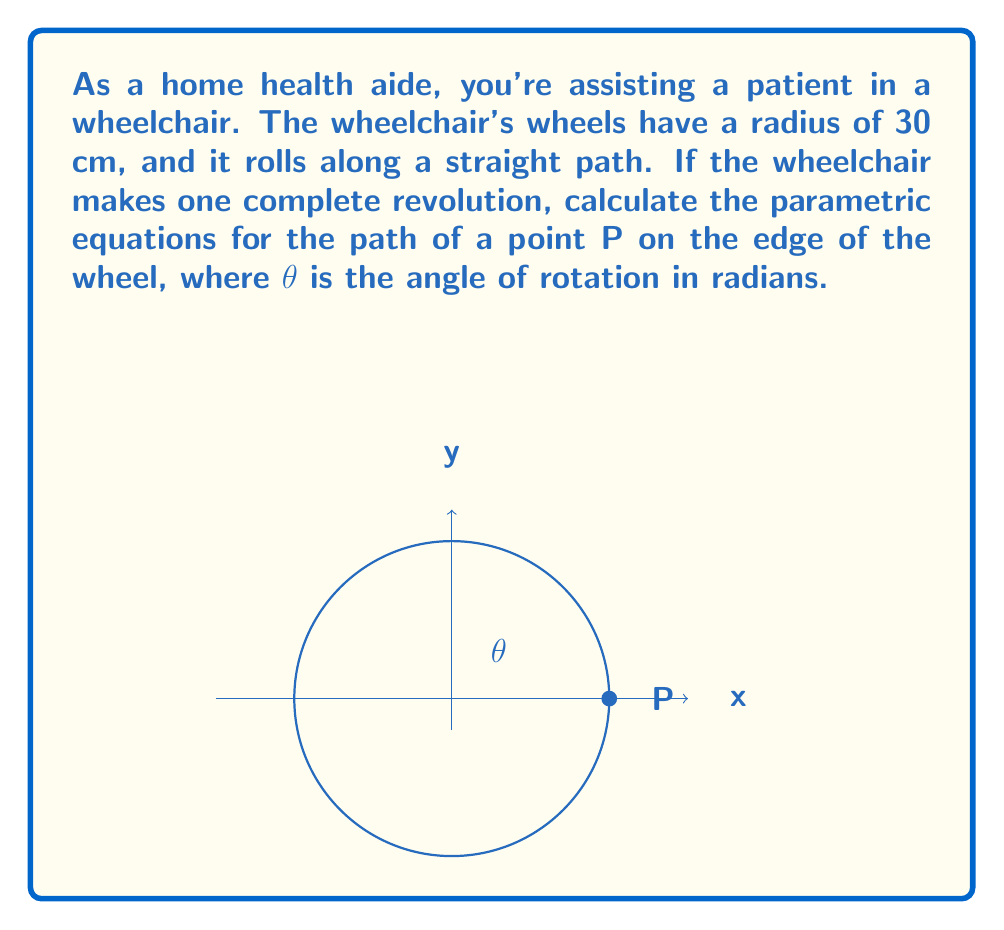Can you solve this math problem? Let's approach this step-by-step:

1) For a wheel rolling without slipping, the parametric equations are:
   $$x = r(\theta - \sin\theta)$$
   $$y = r(1 - \cos\theta)$$
   where r is the radius of the wheel.

2) We're given that the radius is 30 cm. Let's substitute this:
   $$x = 30(\theta - \sin\theta)$$
   $$y = 30(1 - \cos\theta)$$

3) The parameter θ represents the angle of rotation in radians. One complete revolution is 2π radians.

4) To express these equations in centimeters and radians, we don't need to make any further changes.

5) Therefore, the final parametric equations for the path of point P are:
   $$x = 30(\theta - \sin\theta)$$
   $$y = 30(1 - \cos\theta)$$
   where $0 \leq \theta \leq 2\pi$
Answer: $x = 30(\theta - \sin\theta)$, $y = 30(1 - \cos\theta)$, $0 \leq \theta \leq 2\pi$ 